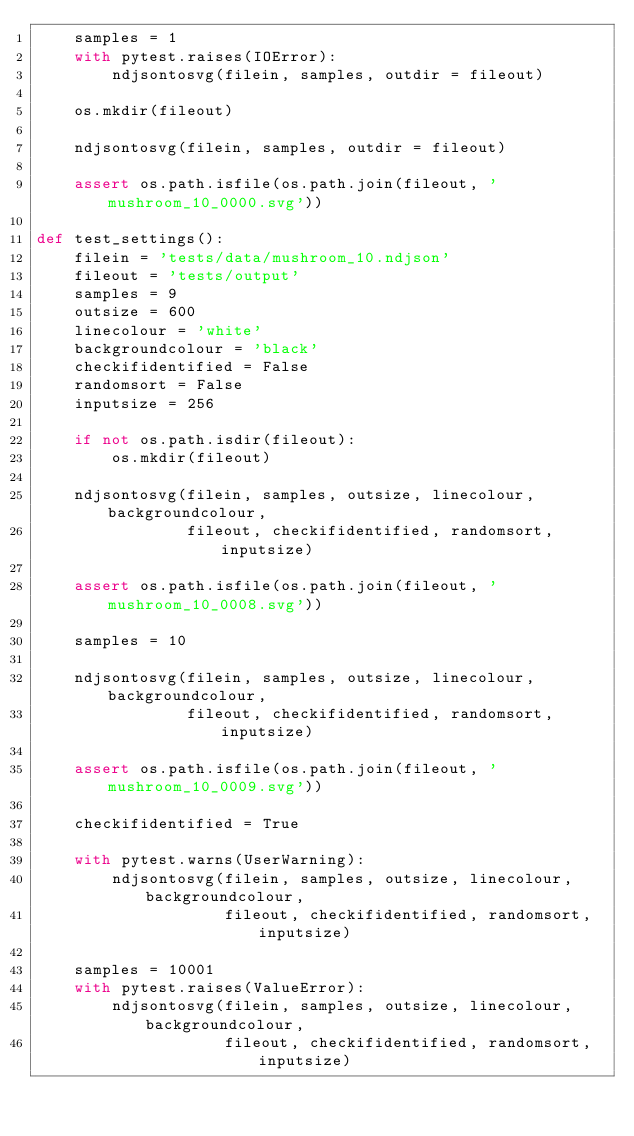Convert code to text. <code><loc_0><loc_0><loc_500><loc_500><_Python_>    samples = 1
    with pytest.raises(IOError):
        ndjsontosvg(filein, samples, outdir = fileout)

    os.mkdir(fileout)

    ndjsontosvg(filein, samples, outdir = fileout)
    
    assert os.path.isfile(os.path.join(fileout, 'mushroom_10_0000.svg'))

def test_settings():
    filein = 'tests/data/mushroom_10.ndjson'
    fileout = 'tests/output'
    samples = 9
    outsize = 600
    linecolour = 'white'
    backgroundcolour = 'black'
    checkifidentified = False
    randomsort = False
    inputsize = 256
    
    if not os.path.isdir(fileout):
        os.mkdir(fileout)

    ndjsontosvg(filein, samples, outsize, linecolour, backgroundcolour,
                fileout, checkifidentified, randomsort, inputsize)

    assert os.path.isfile(os.path.join(fileout, 'mushroom_10_0008.svg'))
    
    samples = 10

    ndjsontosvg(filein, samples, outsize, linecolour, backgroundcolour,
                fileout, checkifidentified, randomsort, inputsize)

    assert os.path.isfile(os.path.join(fileout, 'mushroom_10_0009.svg'))

    checkifidentified = True
    
    with pytest.warns(UserWarning):
        ndjsontosvg(filein, samples, outsize, linecolour, backgroundcolour,
                    fileout, checkifidentified, randomsort, inputsize)
    
    samples = 10001
    with pytest.raises(ValueError):
        ndjsontosvg(filein, samples, outsize, linecolour, backgroundcolour,
                    fileout, checkifidentified, randomsort, inputsize)
</code> 